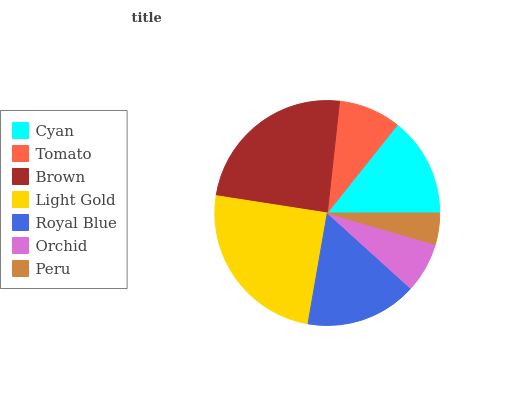Is Peru the minimum?
Answer yes or no. Yes. Is Light Gold the maximum?
Answer yes or no. Yes. Is Tomato the minimum?
Answer yes or no. No. Is Tomato the maximum?
Answer yes or no. No. Is Cyan greater than Tomato?
Answer yes or no. Yes. Is Tomato less than Cyan?
Answer yes or no. Yes. Is Tomato greater than Cyan?
Answer yes or no. No. Is Cyan less than Tomato?
Answer yes or no. No. Is Cyan the high median?
Answer yes or no. Yes. Is Cyan the low median?
Answer yes or no. Yes. Is Light Gold the high median?
Answer yes or no. No. Is Peru the low median?
Answer yes or no. No. 